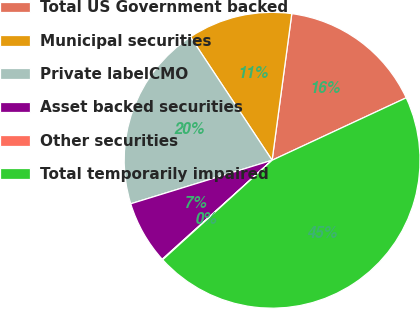<chart> <loc_0><loc_0><loc_500><loc_500><pie_chart><fcel>Total US Government backed<fcel>Municipal securities<fcel>Private labelCMO<fcel>Asset backed securities<fcel>Other securities<fcel>Total temporarily impaired<nl><fcel>15.94%<fcel>11.43%<fcel>20.45%<fcel>6.92%<fcel>0.07%<fcel>45.19%<nl></chart> 